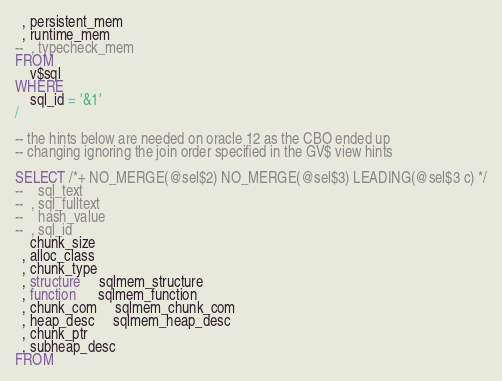Convert code to text. <code><loc_0><loc_0><loc_500><loc_500><_SQL_>  , persistent_mem
  , runtime_mem
--  , typecheck_mem
FROM
    v$sql
WHERE
    sql_id = '&1'
/

-- the hints below are needed on oracle 12 as the CBO ended up
-- changing ignoring the join order specified in the GV$ view hints

SELECT /*+ NO_MERGE(@sel$2) NO_MERGE(@sel$3) LEADING(@sel$3 c) */
--    sql_text
--  , sql_fulltext
--    hash_value
--  , sql_id
    chunk_size
  , alloc_class
  , chunk_type
  , structure     sqlmem_structure
  , function      sqlmem_function
  , chunk_com     sqlmem_chunk_com
  , heap_desc     sqlmem_heap_desc
  , chunk_ptr
  , subheap_desc
FROM</code> 